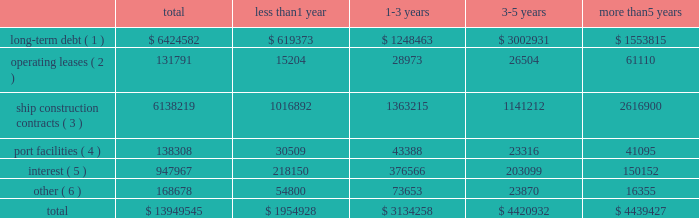Off-balance sheet transactions contractual obligations as of december 31 , 2017 , our contractual obligations with initial or remaining terms in excess of one year , including interest payments on long-term debt obligations , were as follows ( in thousands ) : the table above does not include $ 0.5 million of unrecognized tax benefits ( we refer you to the notes to the consolidated financial statements note 201410 201cincome tax 201d ) .
Certain service providers may require collateral in the normal course of our business .
The amount of collateral may change based on certain terms and conditions .
As a routine part of our business , depending on market conditions , exchange rates , pricing and our strategy for growth , we regularly consider opportunities to enter into contracts for the building of additional ships .
We may also consider the sale of ships , potential acquisitions and strategic alliances .
If any of these transactions were to occur , they may be financed through the incurrence of additional permitted indebtedness , through cash flows from operations , or through the issuance of debt , equity or equity-related securities .
Funding sources certain of our debt agreements contain covenants that , among other things , require us to maintain a minimum level of liquidity , as well as limit our net funded debt-to-capital ratio , maintain certain other ratios and restrict our ability to pay dividends .
Substantially all of our ships and other property and equipment are pledged as collateral for certain of our debt .
We believe we were in compliance with these covenants as of december 31 , 2017 .
The impact of changes in world economies and especially the global credit markets can create a challenging environment and may reduce future consumer demand for cruises and adversely affect our counterparty credit risks .
In the event this environment deteriorates , our business , financial condition and results of operations could be adversely impacted .
We believe our cash on hand , expected future operating cash inflows , additional available borrowings under our new revolving loan facility and our ability to issue debt securities or additional equity securities , will be sufficient to fund operations , debt payment requirements , capital expenditures and maintain compliance with covenants under our debt agreements over the next twelve-month period .
There is no assurance that cash flows from operations and additional financings will be available in the future to fund our future obligations .
Less than 1 year 1-3 years 3-5 years more than 5 years long-term debt ( 1 ) $ 6424582 $ 619373 $ 1248463 $ 3002931 $ 1553815 operating leases ( 2 ) 131791 15204 28973 26504 61110 ship construction contracts ( 3 ) 6138219 1016892 1363215 1141212 2616900 port facilities ( 4 ) 138308 30509 43388 23316 41095 interest ( 5 ) 947967 218150 376566 203099 150152 other ( 6 ) 168678 54800 73653 23870 16355 .
( 1 ) includes discount and premiums aggregating $ 0.5 million .
Also includes capital leases .
The amount excludes deferred financing fees which are included in the consolidated balance sheets as an offset to long-term debt .
( 2 ) primarily for offices , motor vehicles and office equipment .
( 3 ) for our newbuild ships based on the euro/u.s .
Dollar exchange rate as of december 31 , 2017 .
Export credit financing is in place from syndicates of banks .
( 4 ) primarily for our usage of certain port facilities .
( 5 ) includes fixed and variable rates with libor held constant as of december 31 , 2017 .
( 6 ) future commitments for service , maintenance and other business enhancement capital expenditure contracts. .
What percentage of payments was long-term debt? 
Rationale: to find the percentage of payments was long-term debt one must divide long-term debt by the total amount of payments .
Computations: (6424582 / 13949545)
Answer: 0.46056. 